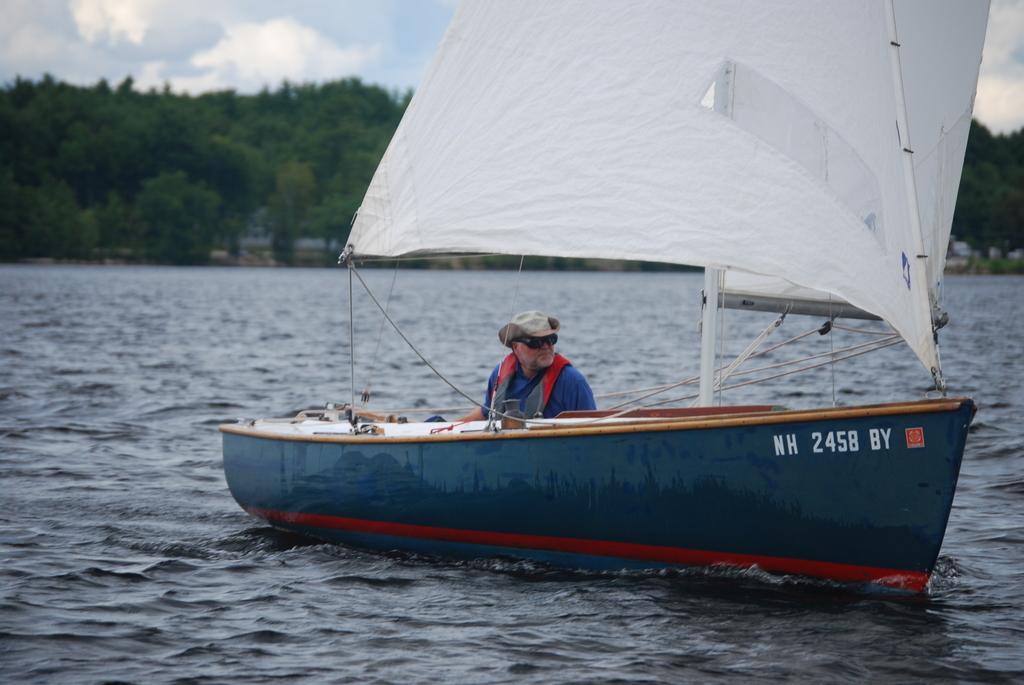Could you give a brief overview of what you see in this image? In this image we can see a boat and one man is sitting in the boat. The background of the image trees are there. The sky is covered with clouds. Bottom of the image water is there. 